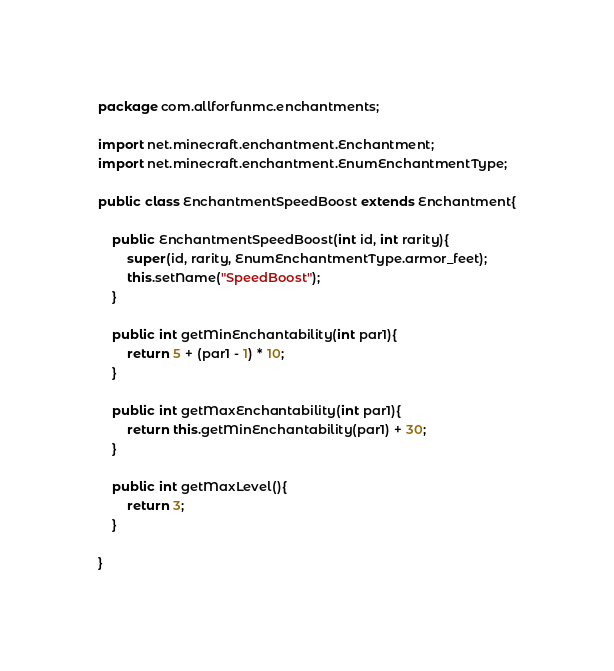Convert code to text. <code><loc_0><loc_0><loc_500><loc_500><_Java_>package com.allforfunmc.enchantments;

import net.minecraft.enchantment.Enchantment;
import net.minecraft.enchantment.EnumEnchantmentType;

public class EnchantmentSpeedBoost extends Enchantment{
	
	public EnchantmentSpeedBoost(int id, int rarity){
		super(id, rarity, EnumEnchantmentType.armor_feet);
		this.setName("SpeedBoost");
	}
	
	public int getMinEnchantability(int par1){
		return 5 + (par1 - 1) * 10;
	}
	
	public int getMaxEnchantability(int par1){
		return this.getMinEnchantability(par1) + 30;
	}
	
	public int getMaxLevel(){
		return 3;
	}

}
</code> 